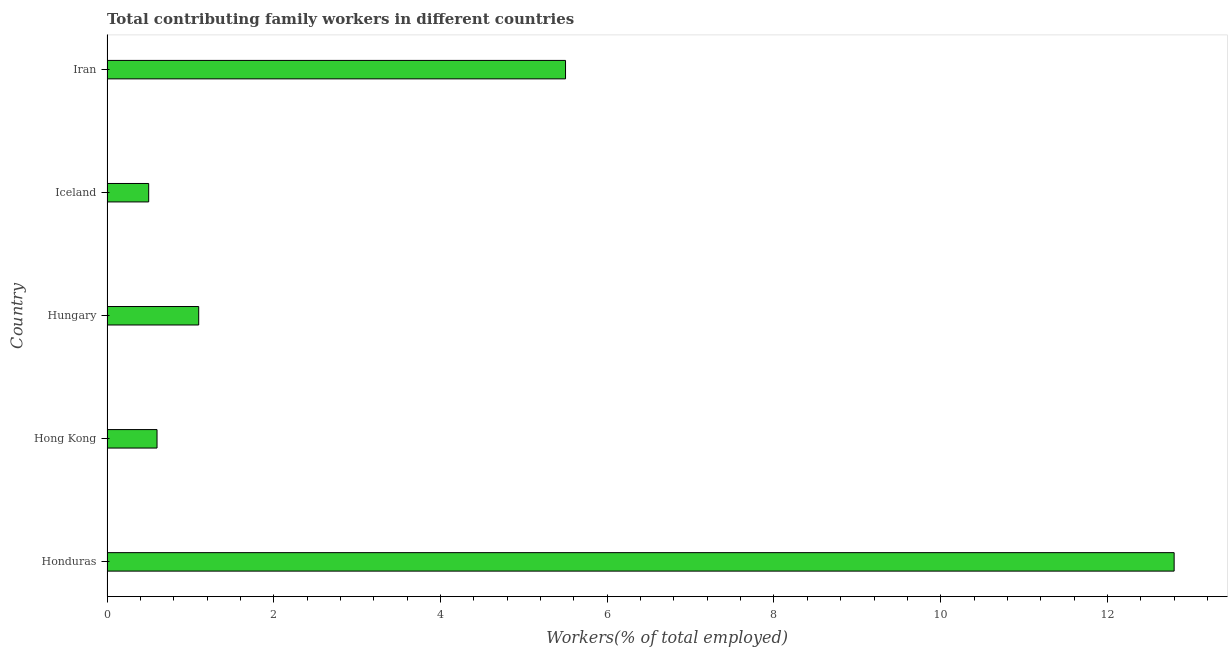Does the graph contain grids?
Ensure brevity in your answer.  No. What is the title of the graph?
Keep it short and to the point. Total contributing family workers in different countries. What is the label or title of the X-axis?
Give a very brief answer. Workers(% of total employed). What is the contributing family workers in Honduras?
Make the answer very short. 12.8. Across all countries, what is the maximum contributing family workers?
Give a very brief answer. 12.8. In which country was the contributing family workers maximum?
Keep it short and to the point. Honduras. In which country was the contributing family workers minimum?
Offer a terse response. Iceland. What is the sum of the contributing family workers?
Give a very brief answer. 20.5. What is the difference between the contributing family workers in Honduras and Iceland?
Ensure brevity in your answer.  12.3. What is the average contributing family workers per country?
Provide a succinct answer. 4.1. What is the median contributing family workers?
Your answer should be very brief. 1.1. In how many countries, is the contributing family workers greater than 7.2 %?
Keep it short and to the point. 1. What is the ratio of the contributing family workers in Hong Kong to that in Iceland?
Provide a succinct answer. 1.2. Is the contributing family workers in Iceland less than that in Iran?
Ensure brevity in your answer.  Yes. What is the difference between the highest and the second highest contributing family workers?
Your answer should be very brief. 7.3. How many countries are there in the graph?
Ensure brevity in your answer.  5. What is the difference between two consecutive major ticks on the X-axis?
Offer a very short reply. 2. What is the Workers(% of total employed) of Honduras?
Give a very brief answer. 12.8. What is the Workers(% of total employed) in Hong Kong?
Provide a succinct answer. 0.6. What is the Workers(% of total employed) in Hungary?
Ensure brevity in your answer.  1.1. What is the difference between the Workers(% of total employed) in Honduras and Hong Kong?
Offer a terse response. 12.2. What is the difference between the Workers(% of total employed) in Hong Kong and Hungary?
Give a very brief answer. -0.5. What is the difference between the Workers(% of total employed) in Hong Kong and Iran?
Your response must be concise. -4.9. What is the difference between the Workers(% of total employed) in Iceland and Iran?
Offer a terse response. -5. What is the ratio of the Workers(% of total employed) in Honduras to that in Hong Kong?
Your response must be concise. 21.33. What is the ratio of the Workers(% of total employed) in Honduras to that in Hungary?
Provide a succinct answer. 11.64. What is the ratio of the Workers(% of total employed) in Honduras to that in Iceland?
Offer a very short reply. 25.6. What is the ratio of the Workers(% of total employed) in Honduras to that in Iran?
Your answer should be very brief. 2.33. What is the ratio of the Workers(% of total employed) in Hong Kong to that in Hungary?
Keep it short and to the point. 0.55. What is the ratio of the Workers(% of total employed) in Hong Kong to that in Iceland?
Your response must be concise. 1.2. What is the ratio of the Workers(% of total employed) in Hong Kong to that in Iran?
Make the answer very short. 0.11. What is the ratio of the Workers(% of total employed) in Iceland to that in Iran?
Give a very brief answer. 0.09. 